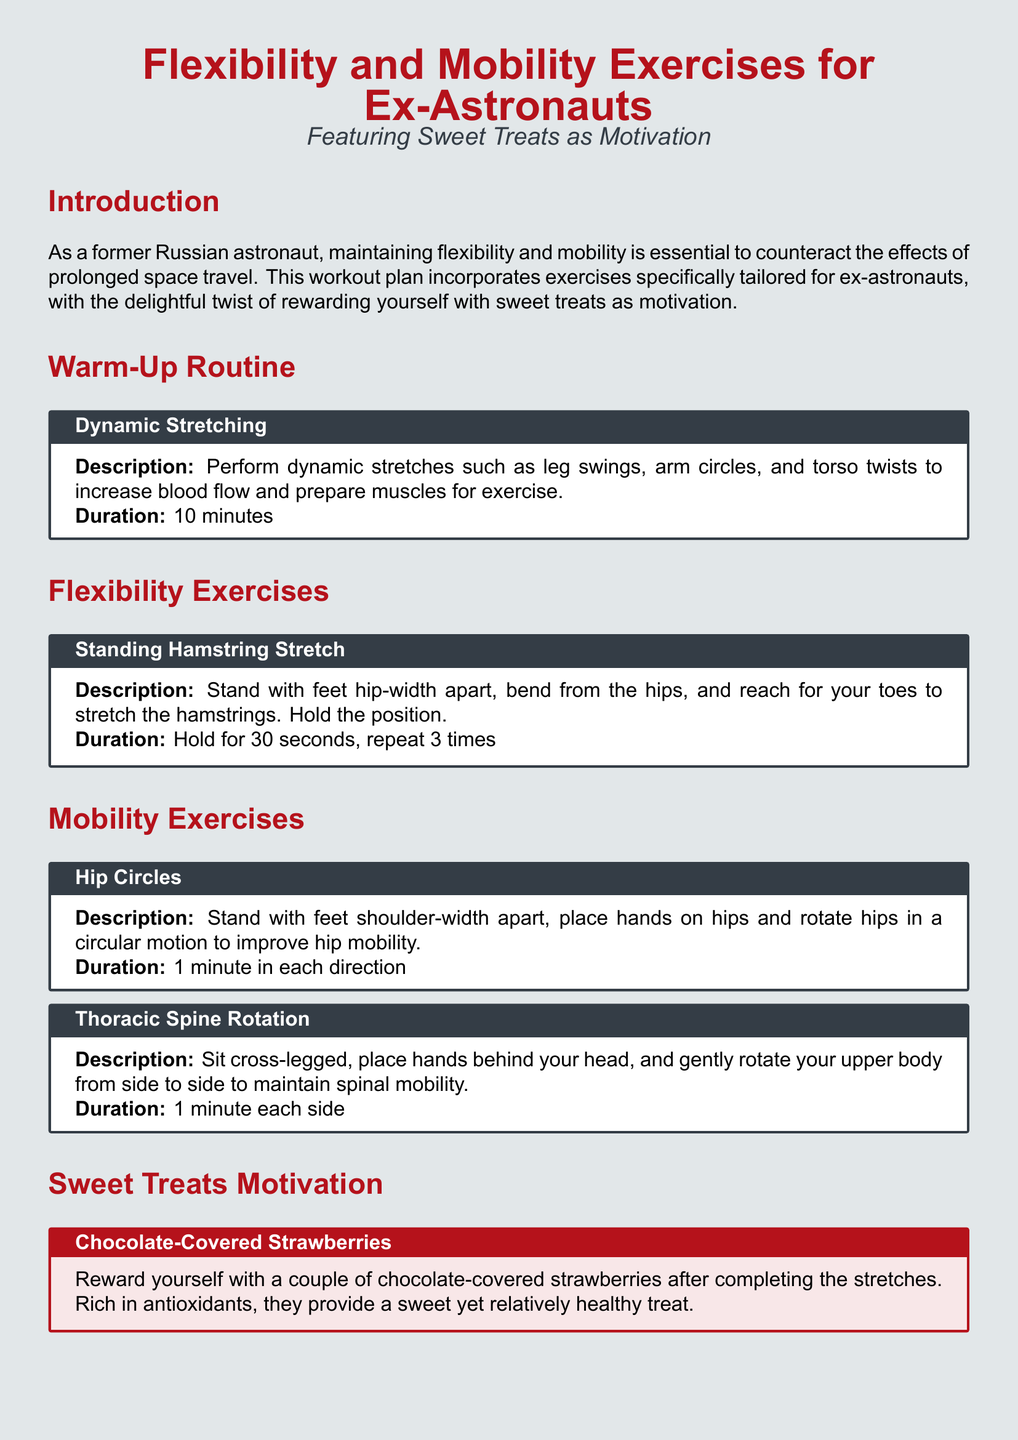What is the duration of the warm-up routine? The warm-up routine consists of dynamic stretching for a duration of 10 minutes.
Answer: 10 minutes What is the title of the first flexibility exercise? The first flexibility exercise mentioned in the document is titled "Standing Hamstring Stretch."
Answer: Standing Hamstring Stretch How long should you hold the standing hamstring stretch? According to the document, the standing hamstring stretch should be held for 30 seconds and repeated 3 times.
Answer: Hold for 30 seconds, repeat 3 times What reward is suggested after completing the stretches? The document suggests rewarding yourself with chocolate-covered strawberries after completing the stretches.
Answer: Chocolate-Covered Strawberries How long should you perform hip circles? The recommended duration for performing hip circles is 1 minute in each direction.
Answer: 1 minute in each direction What is the cool-down exercise mentioned? The cool-down exercise mentioned in the document is "Child's Pose."
Answer: Child's Pose What is the purpose of the workout plan? The purpose of the workout plan is to maintain flexibility and mobility after space travel while incorporating sweet treats as motivation.
Answer: Maintain flexibility and mobility In what position do you perform the thoracic spine rotation? The thoracic spine rotation should be performed while sitting cross-legged.
Answer: Cross-legged How many times should the standing hamstring stretch be repeated? The standing hamstring stretch should be repeated 3 times.
Answer: 3 times 